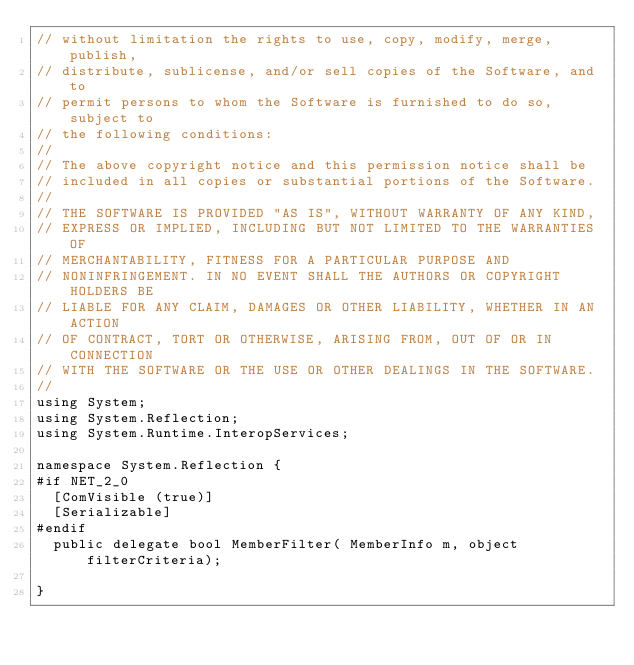<code> <loc_0><loc_0><loc_500><loc_500><_C#_>// without limitation the rights to use, copy, modify, merge, publish,
// distribute, sublicense, and/or sell copies of the Software, and to
// permit persons to whom the Software is furnished to do so, subject to
// the following conditions:
// 
// The above copyright notice and this permission notice shall be
// included in all copies or substantial portions of the Software.
// 
// THE SOFTWARE IS PROVIDED "AS IS", WITHOUT WARRANTY OF ANY KIND,
// EXPRESS OR IMPLIED, INCLUDING BUT NOT LIMITED TO THE WARRANTIES OF
// MERCHANTABILITY, FITNESS FOR A PARTICULAR PURPOSE AND
// NONINFRINGEMENT. IN NO EVENT SHALL THE AUTHORS OR COPYRIGHT HOLDERS BE
// LIABLE FOR ANY CLAIM, DAMAGES OR OTHER LIABILITY, WHETHER IN AN ACTION
// OF CONTRACT, TORT OR OTHERWISE, ARISING FROM, OUT OF OR IN CONNECTION
// WITH THE SOFTWARE OR THE USE OR OTHER DEALINGS IN THE SOFTWARE.
//
using System;
using System.Reflection;
using System.Runtime.InteropServices;

namespace System.Reflection {
#if NET_2_0
	[ComVisible (true)]
	[Serializable]
#endif
	public delegate bool MemberFilter( MemberInfo m, object filterCriteria);

}
</code> 